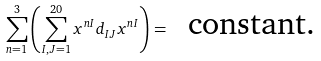<formula> <loc_0><loc_0><loc_500><loc_500>\sum _ { n = 1 } ^ { 3 } \left ( \sum _ { I , J = 1 } ^ { 2 0 } x ^ { n I } d _ { I J } x ^ { n I } \right ) = \text { { constant}.}</formula> 